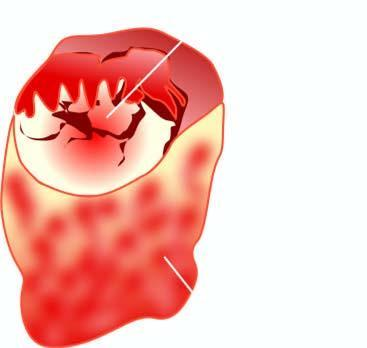what is grey-white soft and shows grossly visible papillary pattern?
Answer the question using a single word or phrase. Nodule 